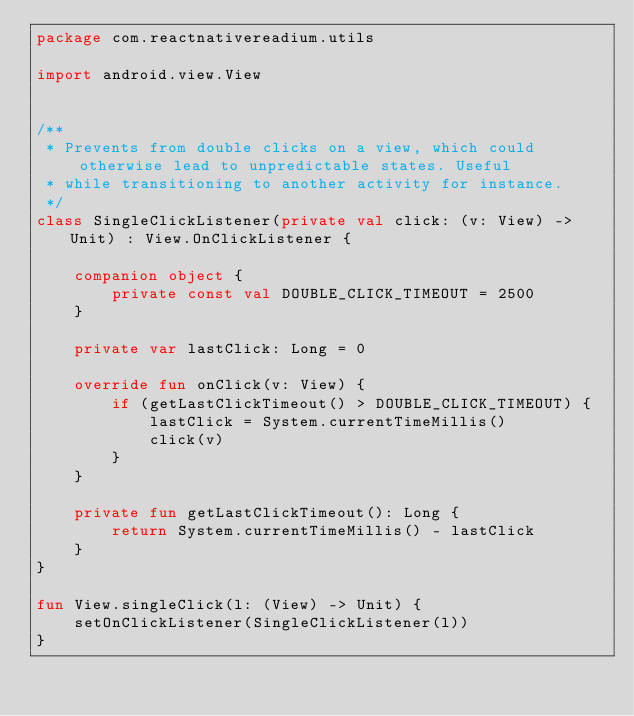Convert code to text. <code><loc_0><loc_0><loc_500><loc_500><_Kotlin_>package com.reactnativereadium.utils

import android.view.View


/**
 * Prevents from double clicks on a view, which could otherwise lead to unpredictable states. Useful
 * while transitioning to another activity for instance.
 */
class SingleClickListener(private val click: (v: View) -> Unit) : View.OnClickListener {

    companion object {
        private const val DOUBLE_CLICK_TIMEOUT = 2500
    }

    private var lastClick: Long = 0

    override fun onClick(v: View) {
        if (getLastClickTimeout() > DOUBLE_CLICK_TIMEOUT) {
            lastClick = System.currentTimeMillis()
            click(v)
        }
    }

    private fun getLastClickTimeout(): Long {
        return System.currentTimeMillis() - lastClick
    }
}

fun View.singleClick(l: (View) -> Unit) {
    setOnClickListener(SingleClickListener(l))
}
</code> 